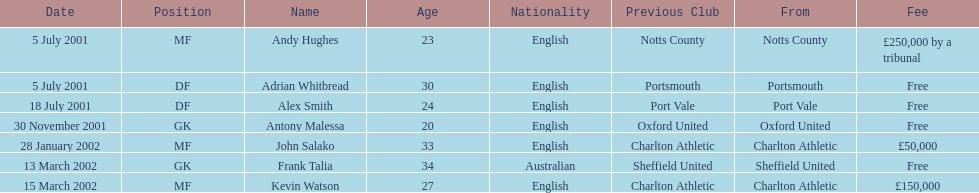Who transferred before 1 august 2001? Andy Hughes, Adrian Whitbread, Alex Smith. 